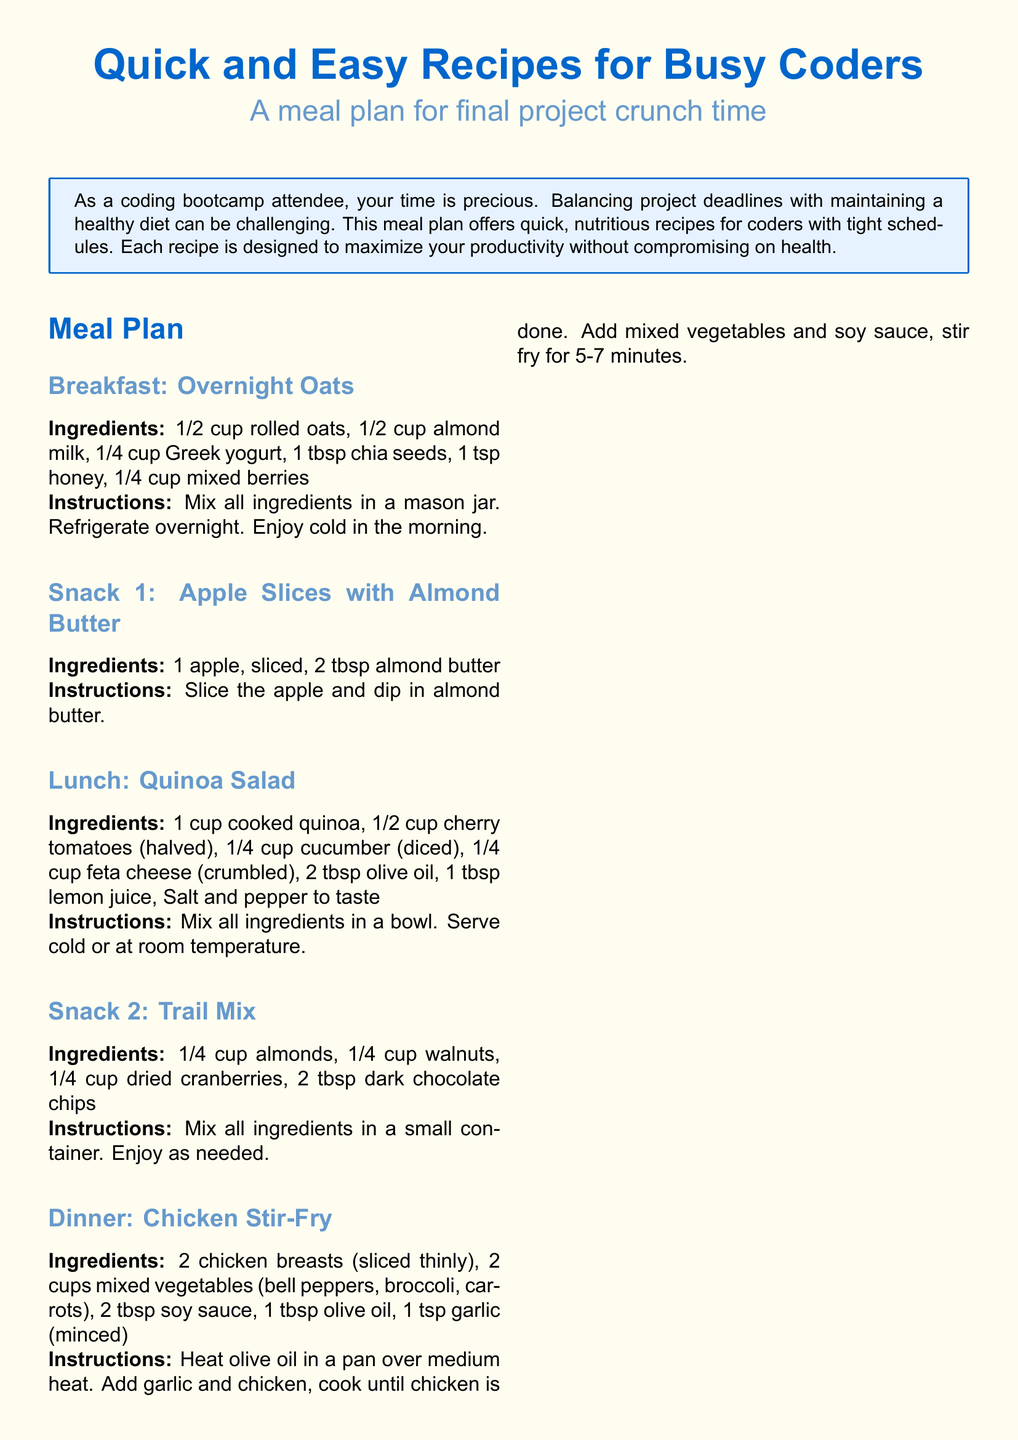What is the title of the document? The title is prominently displayed at the top of the document.
Answer: Quick and Easy Recipes for Busy Coders What is the main focus of the meal plan? The focus is mentioned in the introductory box that summarizes the purpose of the document.
Answer: Quick, nutritious recipes for coders with tight schedules How many snacks are included in the meal plan? The list of meals indicates both Snack 1 and Snack 2 as part of the meal plan.
Answer: 2 What ingredient is used in overnight oats for sweetness? The recipe for overnight oats specifies the ingredient used for sweetness.
Answer: Honey What can you swap for a dairy-free option in overnight oats? The meal swap suggestions include alternatives for various ingredients in the recipes.
Answer: Coconut yogurt Which meal includes chicken as an ingredient? The meal plan specifies Chicken Stir-Fry as the dinner option that contains chicken.
Answer: Chicken Stir-Fry How long should the chicken stir-fry be cooked? The instructions for the chicken stir-fry include a specific cooking time.
Answer: 5-7 minutes What is suggested to reduce cooking time? The time-saving tips section provides suggestions for efficient cooking.
Answer: Use pre-cut vegetables and pre-cooked proteins What is the main protein source in the lunch recipe? The quinoa salad recipe lists quinoa as its main ingredient.
Answer: Quinoa 